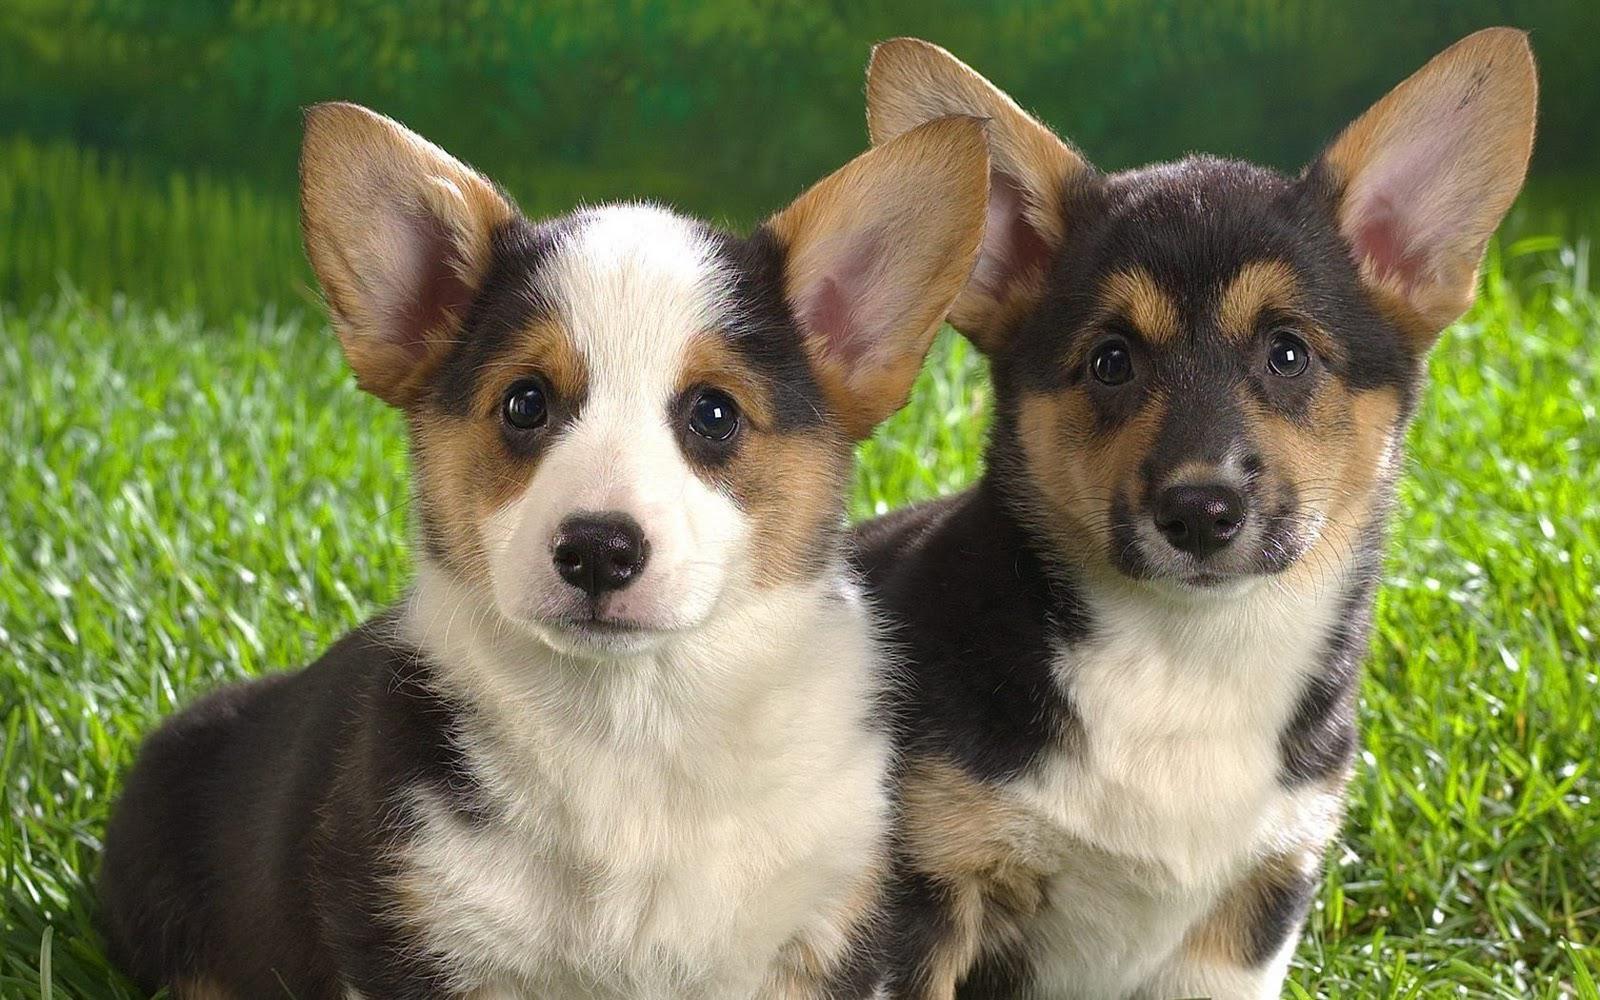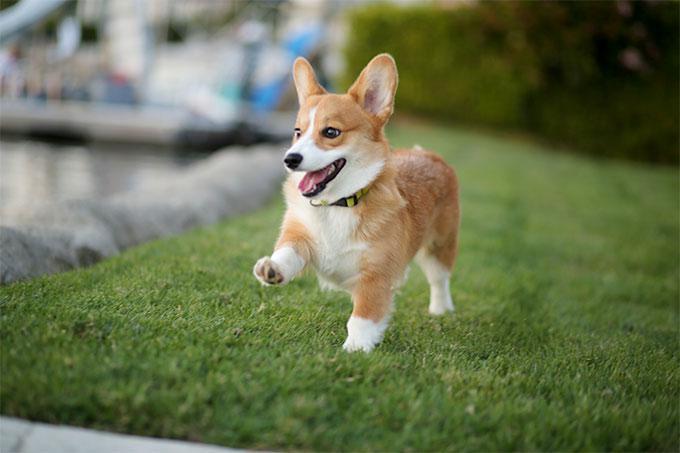The first image is the image on the left, the second image is the image on the right. Considering the images on both sides, is "There are at least three dogs in a grassy area." valid? Answer yes or no. Yes. The first image is the image on the left, the second image is the image on the right. Given the left and right images, does the statement "Each image shows exactly one short-legged dog standing in the grass." hold true? Answer yes or no. No. 